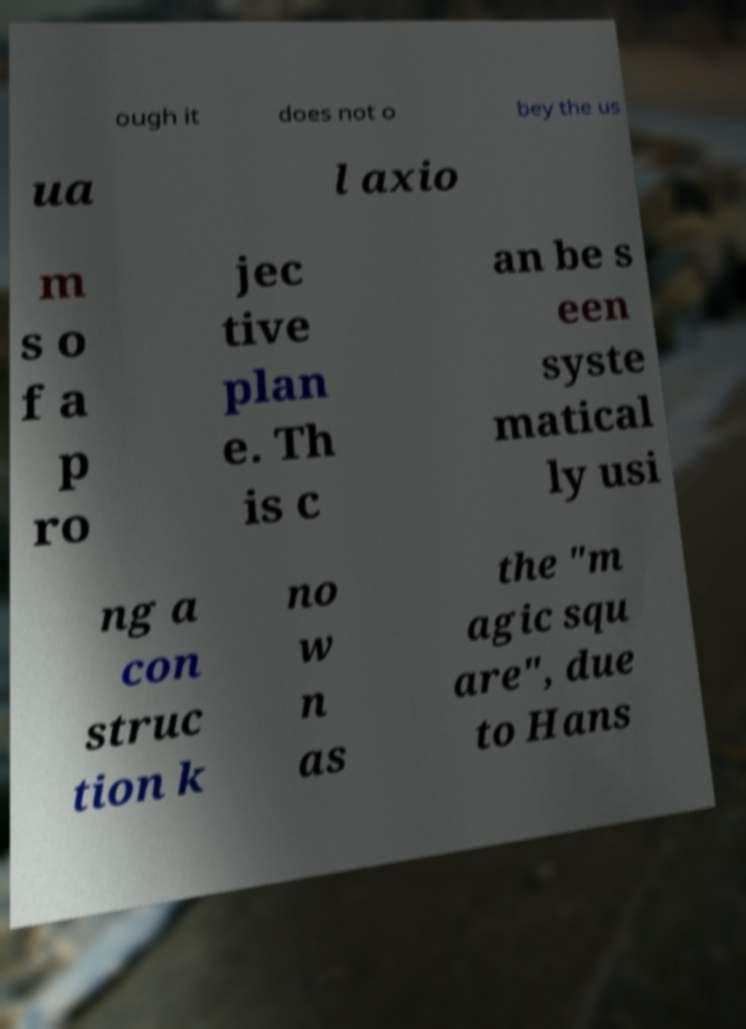Please read and relay the text visible in this image. What does it say? ough it does not o bey the us ua l axio m s o f a p ro jec tive plan e. Th is c an be s een syste matical ly usi ng a con struc tion k no w n as the "m agic squ are", due to Hans 